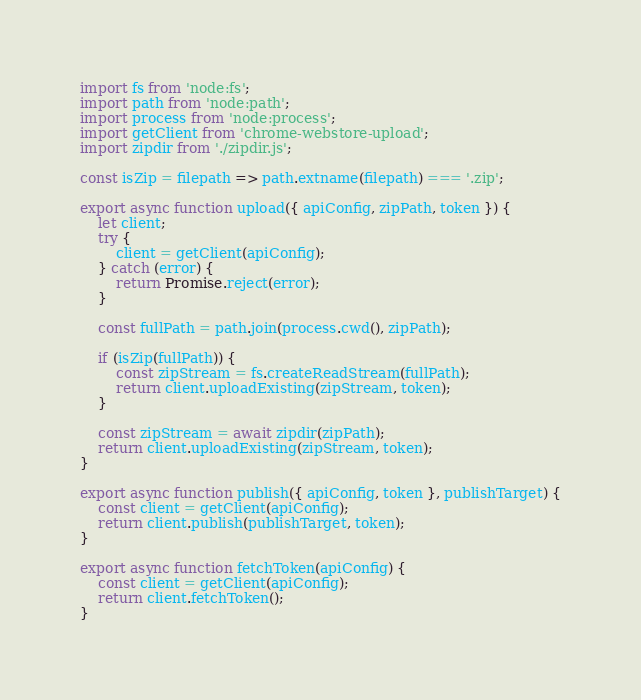Convert code to text. <code><loc_0><loc_0><loc_500><loc_500><_JavaScript_>import fs from 'node:fs';
import path from 'node:path';
import process from 'node:process';
import getClient from 'chrome-webstore-upload';
import zipdir from './zipdir.js';

const isZip = filepath => path.extname(filepath) === '.zip';

export async function upload({ apiConfig, zipPath, token }) {
    let client;
    try {
        client = getClient(apiConfig);
    } catch (error) {
        return Promise.reject(error);
    }

    const fullPath = path.join(process.cwd(), zipPath);

    if (isZip(fullPath)) {
        const zipStream = fs.createReadStream(fullPath);
        return client.uploadExisting(zipStream, token);
    }

    const zipStream = await zipdir(zipPath);
    return client.uploadExisting(zipStream, token);
}

export async function publish({ apiConfig, token }, publishTarget) {
    const client = getClient(apiConfig);
    return client.publish(publishTarget, token);
}

export async function fetchToken(apiConfig) {
    const client = getClient(apiConfig);
    return client.fetchToken();
}
</code> 